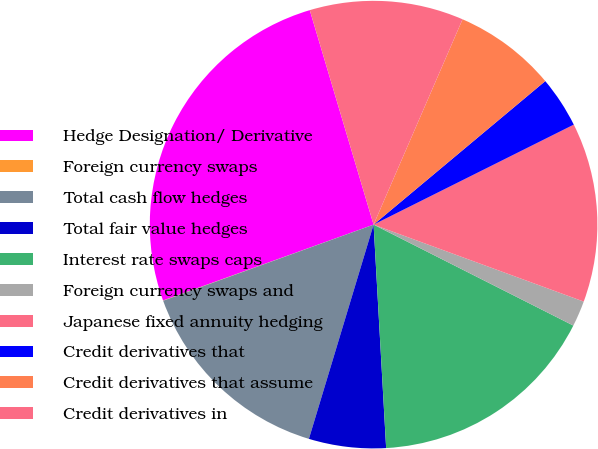Convert chart to OTSL. <chart><loc_0><loc_0><loc_500><loc_500><pie_chart><fcel>Hedge Designation/ Derivative<fcel>Foreign currency swaps<fcel>Total cash flow hedges<fcel>Total fair value hedges<fcel>Interest rate swaps caps<fcel>Foreign currency swaps and<fcel>Japanese fixed annuity hedging<fcel>Credit derivatives that<fcel>Credit derivatives that assume<fcel>Credit derivatives in<nl><fcel>25.9%<fcel>0.02%<fcel>14.81%<fcel>5.56%<fcel>16.66%<fcel>1.86%<fcel>12.96%<fcel>3.71%<fcel>7.41%<fcel>11.11%<nl></chart> 